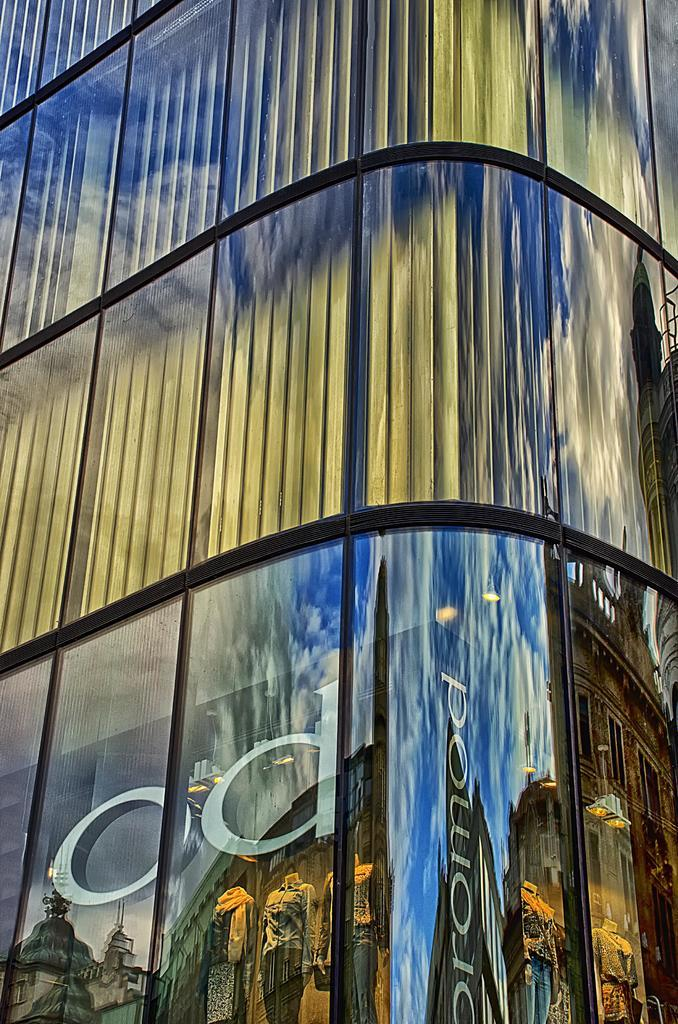What is the main subject in the foreground of the image? There is a wall of a building in the foreground of the image. What can be seen inside the glass on the wall? Inside the glass on the wall, there are mannequins. What is visible in the reflection of the glass? The reflection in the glass shows the sky and buildings. Can you tell me how many muscles the mannequins have in the image? The mannequins in the image are not real people, so they do not have muscles. 